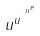<formula> <loc_0><loc_0><loc_500><loc_500>u ^ { u ^ { \cdot ^ { \cdot ^ { u ^ { e } } } } }</formula> 